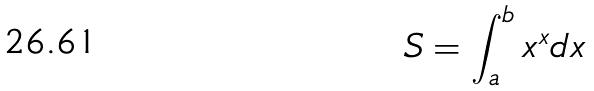<formula> <loc_0><loc_0><loc_500><loc_500>S = \int _ { a } ^ { b } x ^ { x } d x</formula> 